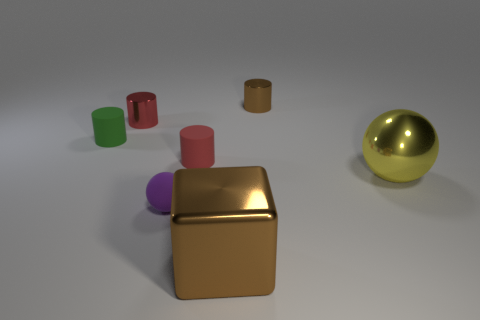Subtract all yellow cylinders. Subtract all yellow cubes. How many cylinders are left? 4 Add 1 small purple objects. How many objects exist? 8 Subtract all cubes. How many objects are left? 6 Subtract all small rubber objects. Subtract all yellow objects. How many objects are left? 3 Add 6 tiny metal things. How many tiny metal things are left? 8 Add 2 big blue balls. How many big blue balls exist? 2 Subtract 0 cyan cylinders. How many objects are left? 7 